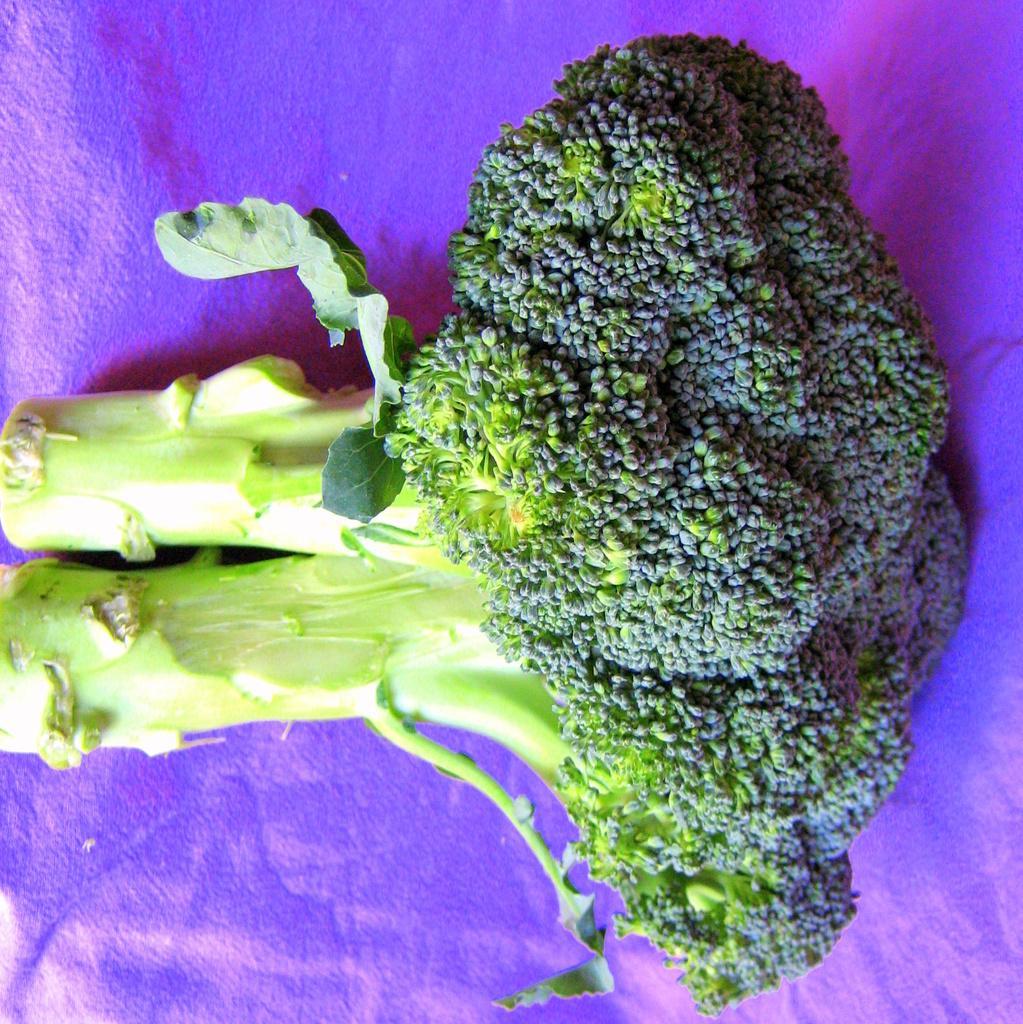Please provide a concise description of this image. In this image, there are two green color vegetables kept on a purple color object. 